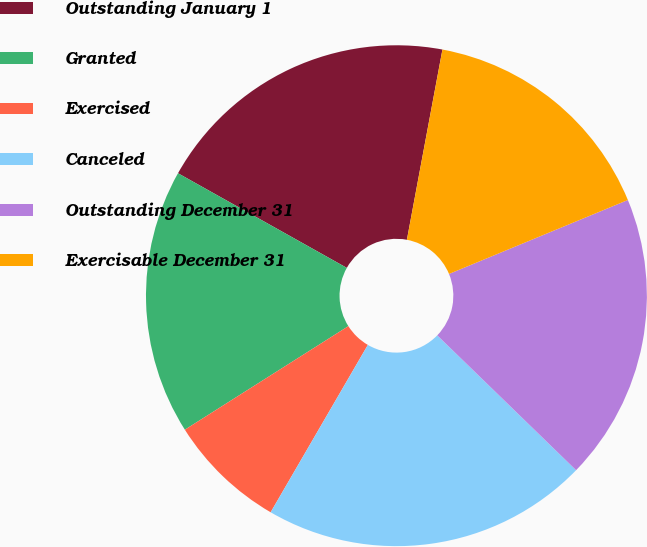Convert chart. <chart><loc_0><loc_0><loc_500><loc_500><pie_chart><fcel>Outstanding January 1<fcel>Granted<fcel>Exercised<fcel>Canceled<fcel>Outstanding December 31<fcel>Exercisable December 31<nl><fcel>19.81%<fcel>17.12%<fcel>7.64%<fcel>21.11%<fcel>18.51%<fcel>15.82%<nl></chart> 